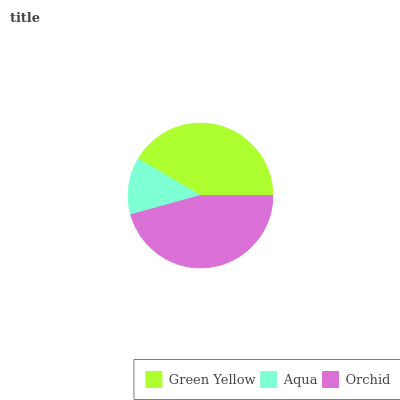Is Aqua the minimum?
Answer yes or no. Yes. Is Orchid the maximum?
Answer yes or no. Yes. Is Orchid the minimum?
Answer yes or no. No. Is Aqua the maximum?
Answer yes or no. No. Is Orchid greater than Aqua?
Answer yes or no. Yes. Is Aqua less than Orchid?
Answer yes or no. Yes. Is Aqua greater than Orchid?
Answer yes or no. No. Is Orchid less than Aqua?
Answer yes or no. No. Is Green Yellow the high median?
Answer yes or no. Yes. Is Green Yellow the low median?
Answer yes or no. Yes. Is Aqua the high median?
Answer yes or no. No. Is Aqua the low median?
Answer yes or no. No. 